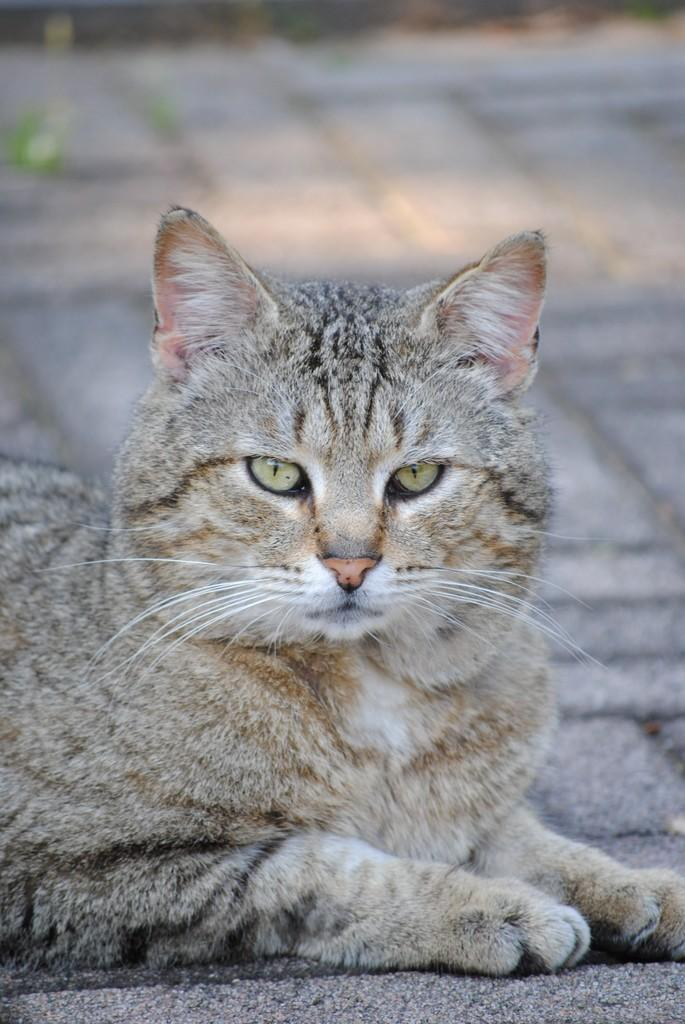What type of animal is in the image? There is a cat in the image. Where is the cat located in the image? The cat is on a surface. What type of gate can be seen in the image? There is no gate present in the image; it only features a cat on a surface. What is the cat doing on the surface in the image? The provided facts do not specify what the cat is doing on the surface, so we cannot answer this question definitively. 